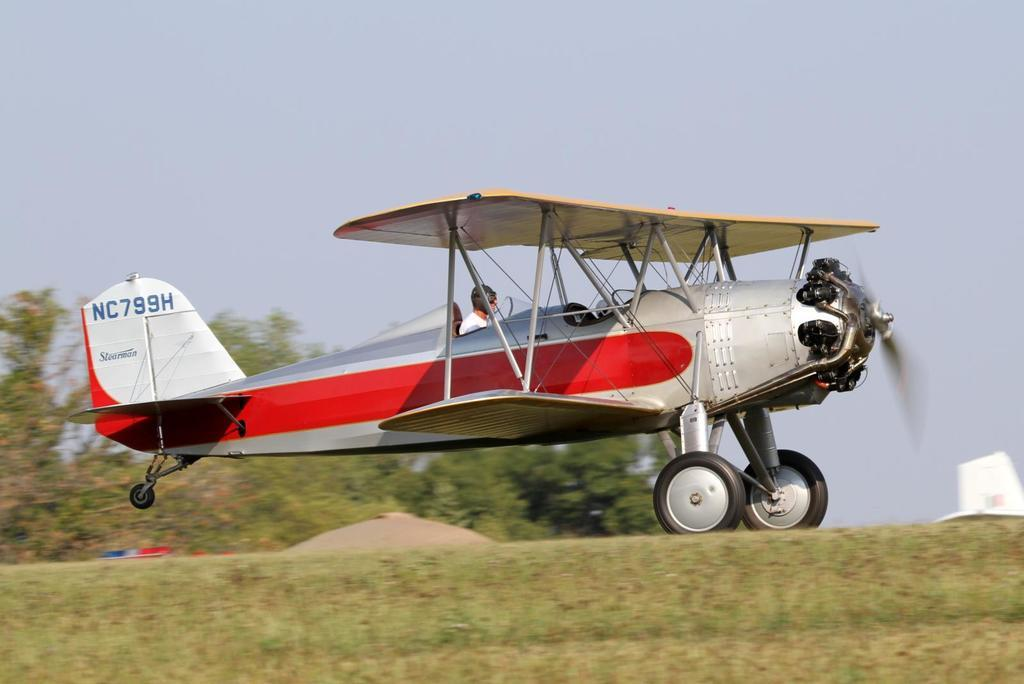<image>
Describe the image concisely. An old fashioned propeller plane bears the Stearman name on its tail. 